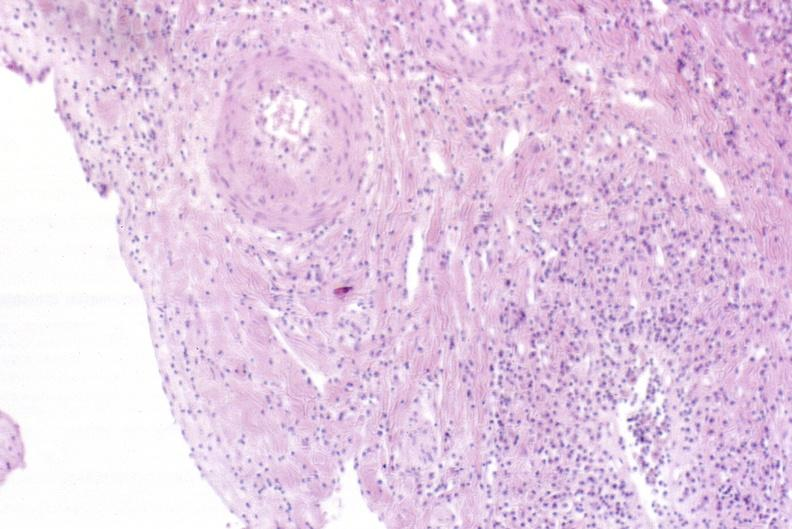s atrophy secondary to pituitectomy present?
Answer the question using a single word or phrase. No 